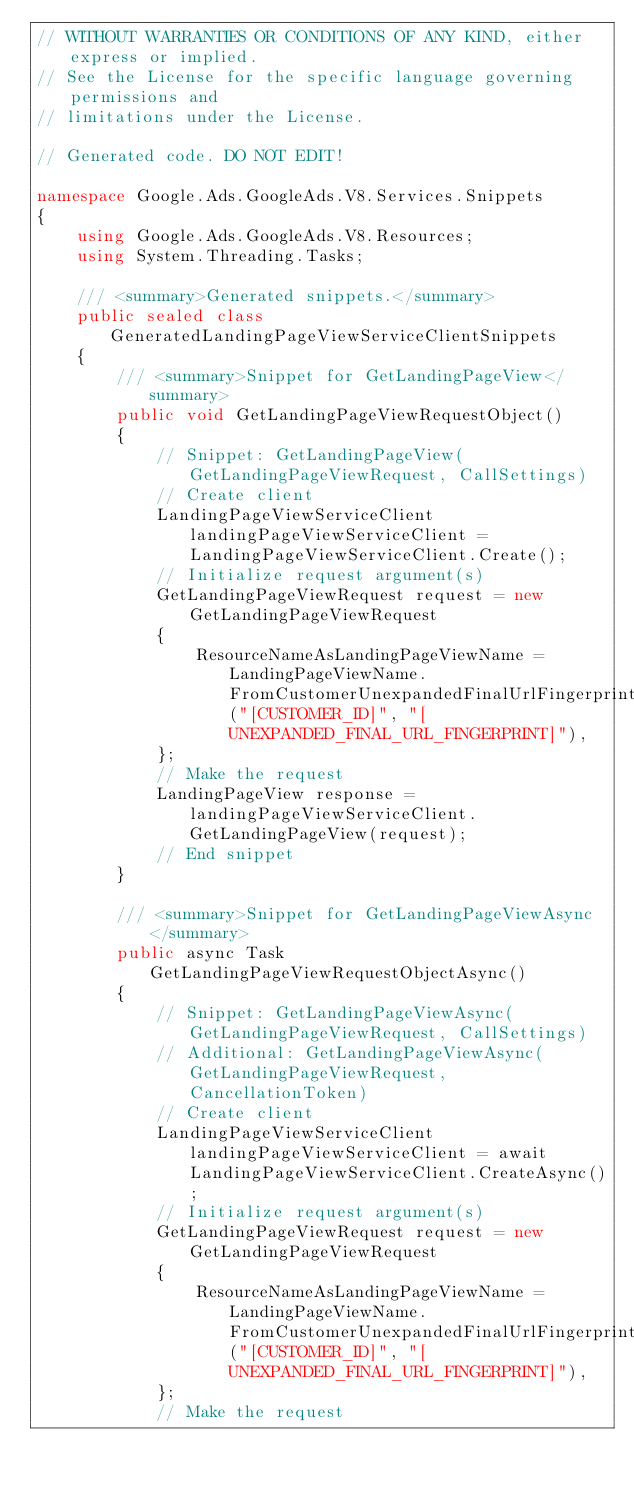<code> <loc_0><loc_0><loc_500><loc_500><_C#_>// WITHOUT WARRANTIES OR CONDITIONS OF ANY KIND, either express or implied.
// See the License for the specific language governing permissions and
// limitations under the License.

// Generated code. DO NOT EDIT!

namespace Google.Ads.GoogleAds.V8.Services.Snippets
{
    using Google.Ads.GoogleAds.V8.Resources;
    using System.Threading.Tasks;

    /// <summary>Generated snippets.</summary>
    public sealed class GeneratedLandingPageViewServiceClientSnippets
    {
        /// <summary>Snippet for GetLandingPageView</summary>
        public void GetLandingPageViewRequestObject()
        {
            // Snippet: GetLandingPageView(GetLandingPageViewRequest, CallSettings)
            // Create client
            LandingPageViewServiceClient landingPageViewServiceClient = LandingPageViewServiceClient.Create();
            // Initialize request argument(s)
            GetLandingPageViewRequest request = new GetLandingPageViewRequest
            {
                ResourceNameAsLandingPageViewName = LandingPageViewName.FromCustomerUnexpandedFinalUrlFingerprint("[CUSTOMER_ID]", "[UNEXPANDED_FINAL_URL_FINGERPRINT]"),
            };
            // Make the request
            LandingPageView response = landingPageViewServiceClient.GetLandingPageView(request);
            // End snippet
        }

        /// <summary>Snippet for GetLandingPageViewAsync</summary>
        public async Task GetLandingPageViewRequestObjectAsync()
        {
            // Snippet: GetLandingPageViewAsync(GetLandingPageViewRequest, CallSettings)
            // Additional: GetLandingPageViewAsync(GetLandingPageViewRequest, CancellationToken)
            // Create client
            LandingPageViewServiceClient landingPageViewServiceClient = await LandingPageViewServiceClient.CreateAsync();
            // Initialize request argument(s)
            GetLandingPageViewRequest request = new GetLandingPageViewRequest
            {
                ResourceNameAsLandingPageViewName = LandingPageViewName.FromCustomerUnexpandedFinalUrlFingerprint("[CUSTOMER_ID]", "[UNEXPANDED_FINAL_URL_FINGERPRINT]"),
            };
            // Make the request</code> 